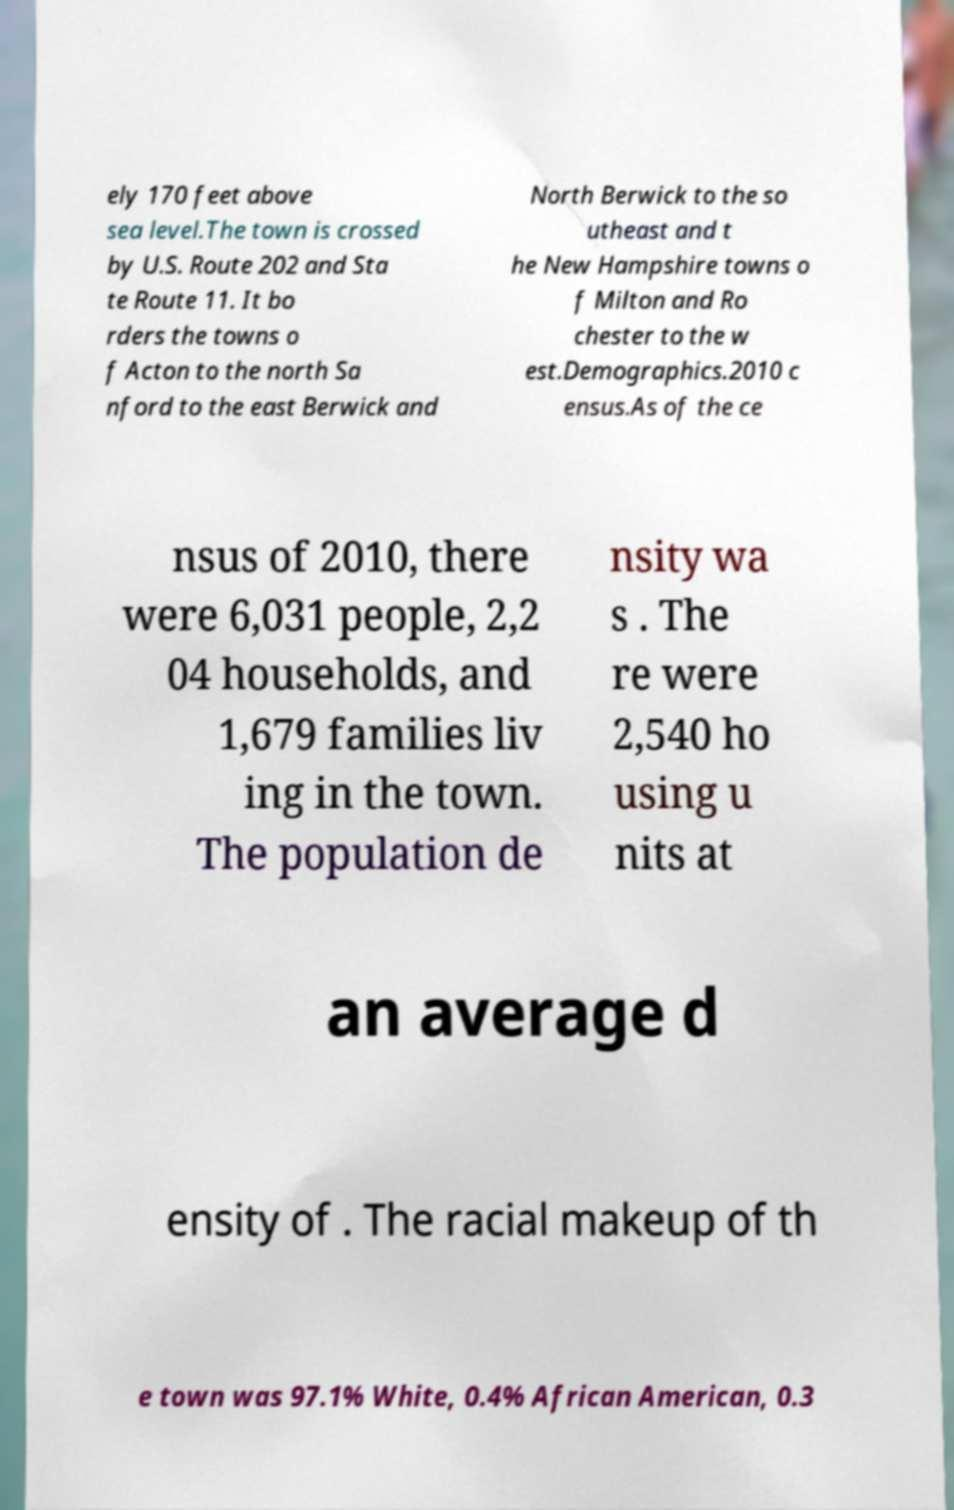Can you read and provide the text displayed in the image?This photo seems to have some interesting text. Can you extract and type it out for me? ely 170 feet above sea level.The town is crossed by U.S. Route 202 and Sta te Route 11. It bo rders the towns o f Acton to the north Sa nford to the east Berwick and North Berwick to the so utheast and t he New Hampshire towns o f Milton and Ro chester to the w est.Demographics.2010 c ensus.As of the ce nsus of 2010, there were 6,031 people, 2,2 04 households, and 1,679 families liv ing in the town. The population de nsity wa s . The re were 2,540 ho using u nits at an average d ensity of . The racial makeup of th e town was 97.1% White, 0.4% African American, 0.3 